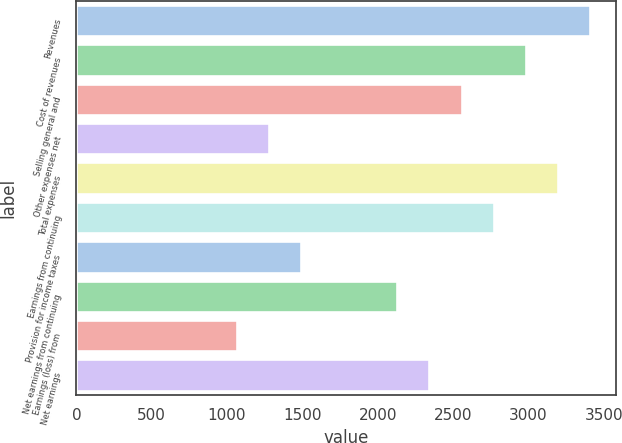Convert chart to OTSL. <chart><loc_0><loc_0><loc_500><loc_500><bar_chart><fcel>Revenues<fcel>Cost of revenues<fcel>Selling general and<fcel>Other expenses net<fcel>Total expenses<fcel>Earnings from continuing<fcel>Provision for income taxes<fcel>Net earnings from continuing<fcel>Earnings (loss) from<fcel>Net earnings<nl><fcel>3409.2<fcel>2983.08<fcel>2556.96<fcel>1278.6<fcel>3196.14<fcel>2770.02<fcel>1491.66<fcel>2130.84<fcel>1065.54<fcel>2343.9<nl></chart> 